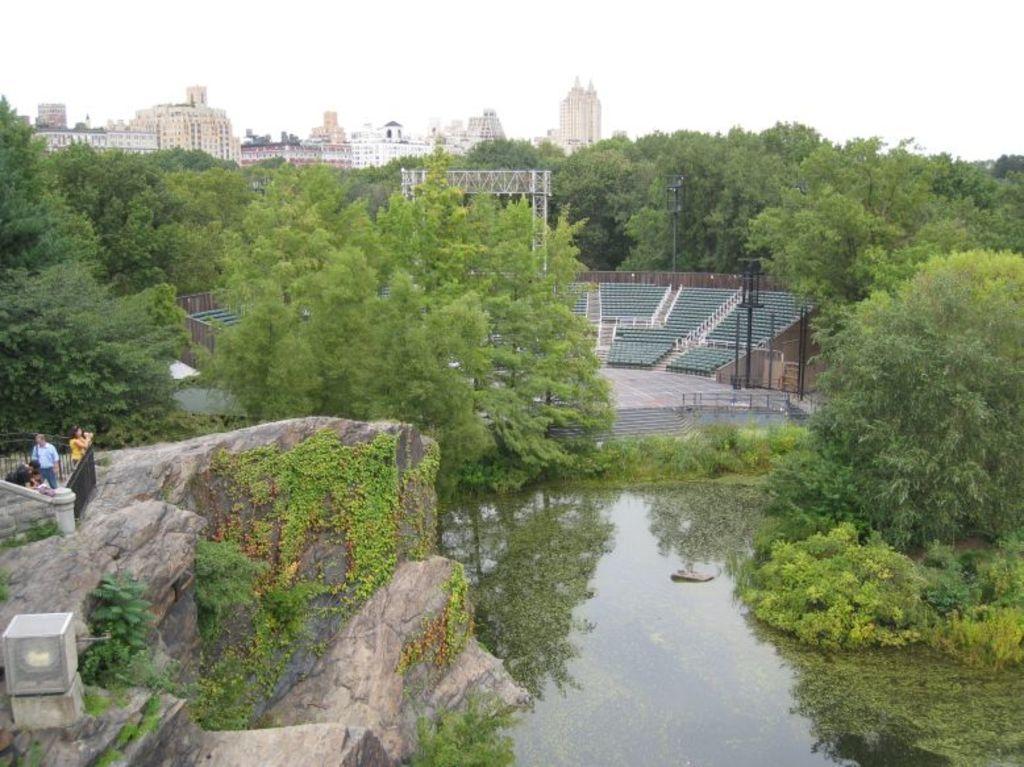Can you describe this image briefly? In this picture i can see the stadium, beside that i can see many trees. At the bottom there is water. On the left there is a man who is wearing shirt, jeans and he is standing near to the black fencing. Beside him there is a woman who is holding a camera. In the background i can see many buildings. At the top there is a sky. In the bottom right corner i can see the plants and grass. 